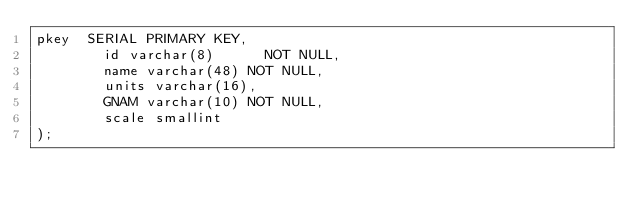<code> <loc_0><loc_0><loc_500><loc_500><_SQL_>pkey  SERIAL PRIMARY KEY,
        id varchar(8)      NOT NULL,
        name varchar(48) NOT NULL,
        units varchar(16),
        GNAM varchar(10) NOT NULL,
        scale smallint
);

</code> 